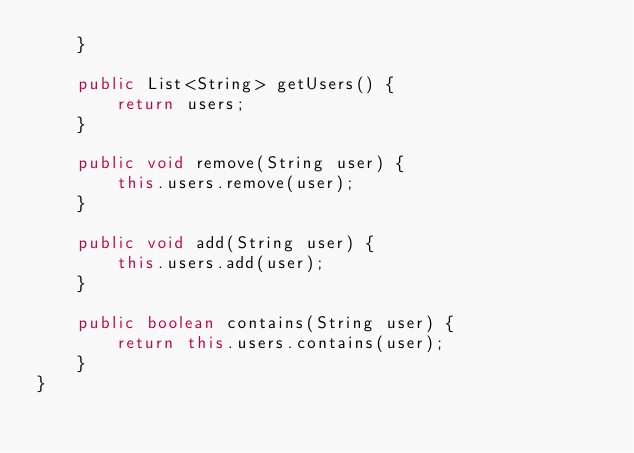Convert code to text. <code><loc_0><loc_0><loc_500><loc_500><_Java_>    }
 
    public List<String> getUsers() {
        return users;
    }
     
    public void remove(String user) {
        this.users.remove(user);
    }
     
    public void add(String user) {
        this.users.add(user);
    }
         
    public boolean contains(String user) {
        return this.users.contains(user);
    }
}
</code> 